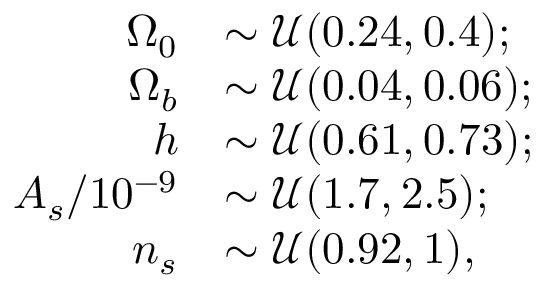Convert formula to latex. <formula><loc_0><loc_0><loc_500><loc_500>\begin{array} { r l } { \Omega _ { 0 } } & { \sim \mathcal { U } ( 0 . 2 4 , 0 . 4 ) ; } \\ { \Omega _ { b } } & { \sim \mathcal { U } ( 0 . 0 4 , 0 . 0 6 ) ; } \\ { h } & { \sim \mathcal { U } ( 0 . 6 1 , 0 . 7 3 ) ; } \\ { A _ { s } / 1 0 ^ { - 9 } } & { \sim \mathcal { U } ( 1 . 7 , 2 . 5 ) ; } \\ { n _ { s } } & { \sim \mathcal { U } ( 0 . 9 2 , 1 ) , } \end{array}</formula> 